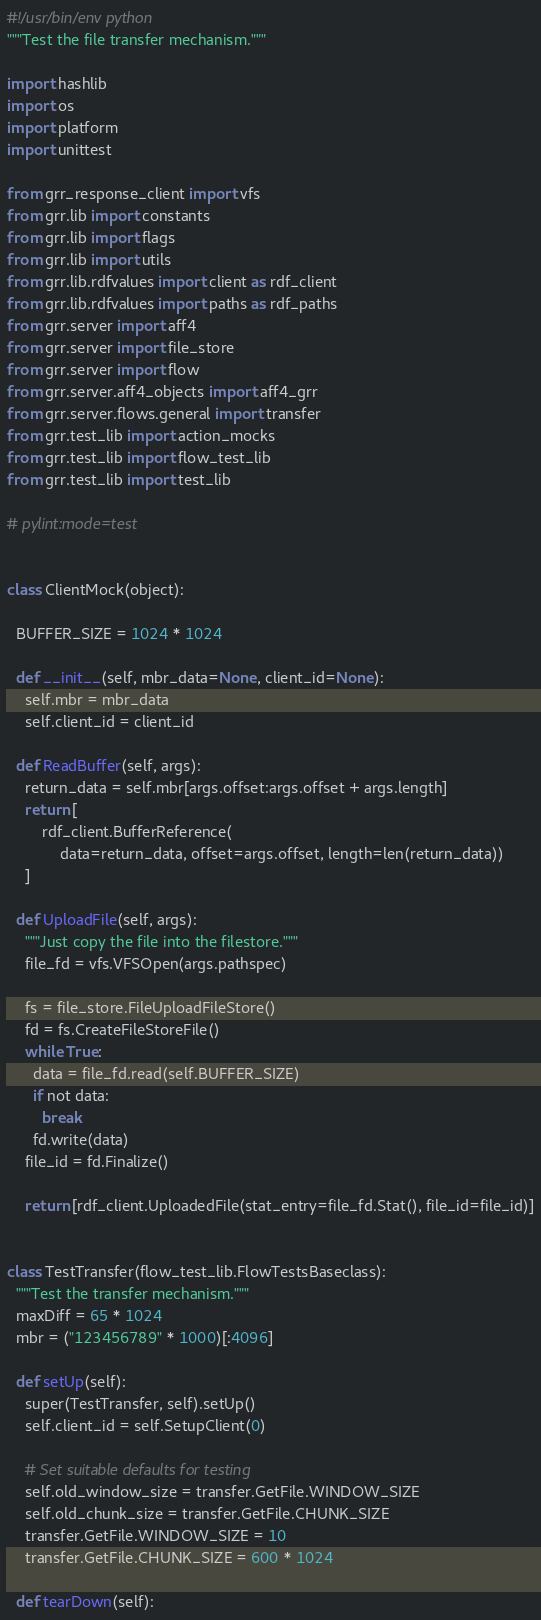<code> <loc_0><loc_0><loc_500><loc_500><_Python_>#!/usr/bin/env python
"""Test the file transfer mechanism."""

import hashlib
import os
import platform
import unittest

from grr_response_client import vfs
from grr.lib import constants
from grr.lib import flags
from grr.lib import utils
from grr.lib.rdfvalues import client as rdf_client
from grr.lib.rdfvalues import paths as rdf_paths
from grr.server import aff4
from grr.server import file_store
from grr.server import flow
from grr.server.aff4_objects import aff4_grr
from grr.server.flows.general import transfer
from grr.test_lib import action_mocks
from grr.test_lib import flow_test_lib
from grr.test_lib import test_lib

# pylint:mode=test


class ClientMock(object):

  BUFFER_SIZE = 1024 * 1024

  def __init__(self, mbr_data=None, client_id=None):
    self.mbr = mbr_data
    self.client_id = client_id

  def ReadBuffer(self, args):
    return_data = self.mbr[args.offset:args.offset + args.length]
    return [
        rdf_client.BufferReference(
            data=return_data, offset=args.offset, length=len(return_data))
    ]

  def UploadFile(self, args):
    """Just copy the file into the filestore."""
    file_fd = vfs.VFSOpen(args.pathspec)

    fs = file_store.FileUploadFileStore()
    fd = fs.CreateFileStoreFile()
    while True:
      data = file_fd.read(self.BUFFER_SIZE)
      if not data:
        break
      fd.write(data)
    file_id = fd.Finalize()

    return [rdf_client.UploadedFile(stat_entry=file_fd.Stat(), file_id=file_id)]


class TestTransfer(flow_test_lib.FlowTestsBaseclass):
  """Test the transfer mechanism."""
  maxDiff = 65 * 1024
  mbr = ("123456789" * 1000)[:4096]

  def setUp(self):
    super(TestTransfer, self).setUp()
    self.client_id = self.SetupClient(0)

    # Set suitable defaults for testing
    self.old_window_size = transfer.GetFile.WINDOW_SIZE
    self.old_chunk_size = transfer.GetFile.CHUNK_SIZE
    transfer.GetFile.WINDOW_SIZE = 10
    transfer.GetFile.CHUNK_SIZE = 600 * 1024

  def tearDown(self):</code> 